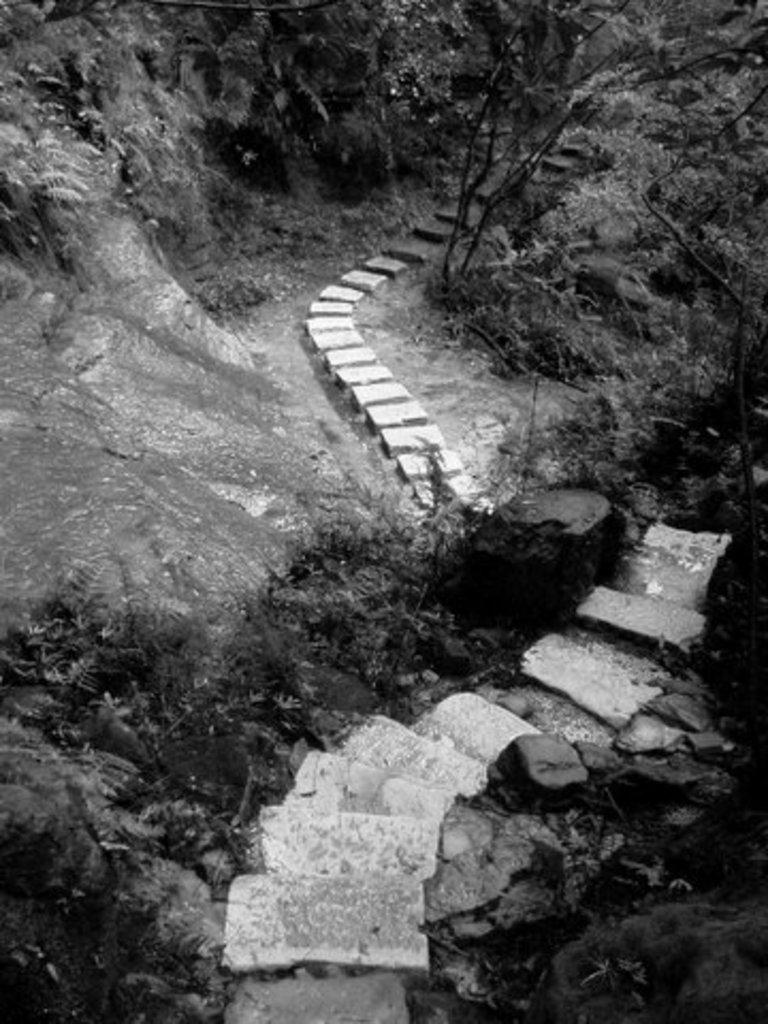What type of architectural feature is present in the image? There are steps in the image. What material is present in the image? There are stones in the image. What can be seen in the background of the image? There are trees in the background of the image. What type of attraction can be seen in the image? There is no attraction present in the image; it only features steps, stones, and trees. What type of quartz is visible in the image? There is no quartz present in the image. 